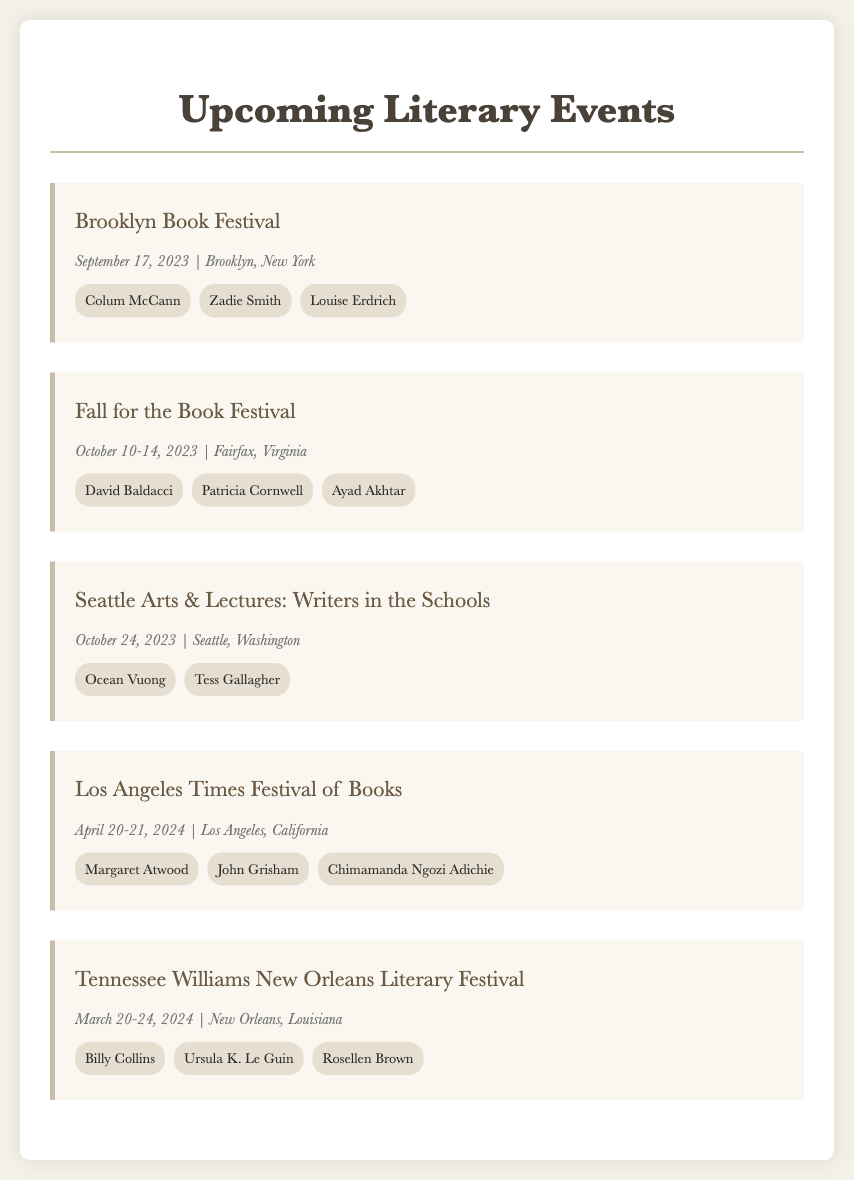What is the date of the Brooklyn Book Festival? The Brooklyn Book Festival occurs on September 17, 2023, as mentioned in the details of the event.
Answer: September 17, 2023 Who is one of the featured authors at the Fall for the Book Festival? The Fall for the Book Festival features David Baldacci, Patricia Cornwell, and Ayad Akhtar as indicated in the event details.
Answer: David Baldacci Which location hosts the Seattle Arts & Lectures: Writers in the Schools event? The event is taking place in Seattle, Washington, as specified in its details.
Answer: Seattle, Washington How many authors are featured at the Los Angeles Times Festival of Books? The document lists three authors: Margaret Atwood, John Grisham, and Chimamanda Ngozi Adichie for this event, providing a count of featured authors.
Answer: Three What are the dates of the Tennessee Williams New Orleans Literary Festival? The festival will occur from March 20 to March 24, 2024, as stated in the event details.
Answer: March 20-24, 2024 Which event takes place in April? The Los Angeles Times Festival of Books takes place on April 20-21, 2024, making it the only April event mentioned.
Answer: Los Angeles Times Festival of Books Who is featured at the event in New Orleans? The featured authors for the Tennessee Williams New Orleans Literary Festival include Billy Collins, Ursula K. Le Guin, and Rosellen Brown, as listed in the document.
Answer: Billy Collins What city is the Fall for the Book Festival located in? The city hosting the Fall for the Book Festival is Fairfax, Virginia, as indicated in the event details.
Answer: Fairfax, Virginia 